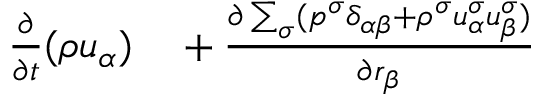<formula> <loc_0><loc_0><loc_500><loc_500>\begin{array} { r } { \begin{array} { r l } { \frac { \partial } { \partial t } ( \rho u _ { \alpha } ) } & + \frac { \partial \sum _ { \sigma } ( p ^ { \sigma } \delta _ { \alpha \beta } + \rho ^ { \sigma } u _ { \alpha } ^ { \sigma } u _ { \beta } ^ { \sigma } ) } { \partial r _ { \beta } } } \end{array} } \end{array}</formula> 